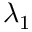<formula> <loc_0><loc_0><loc_500><loc_500>_ { 1 }</formula> 